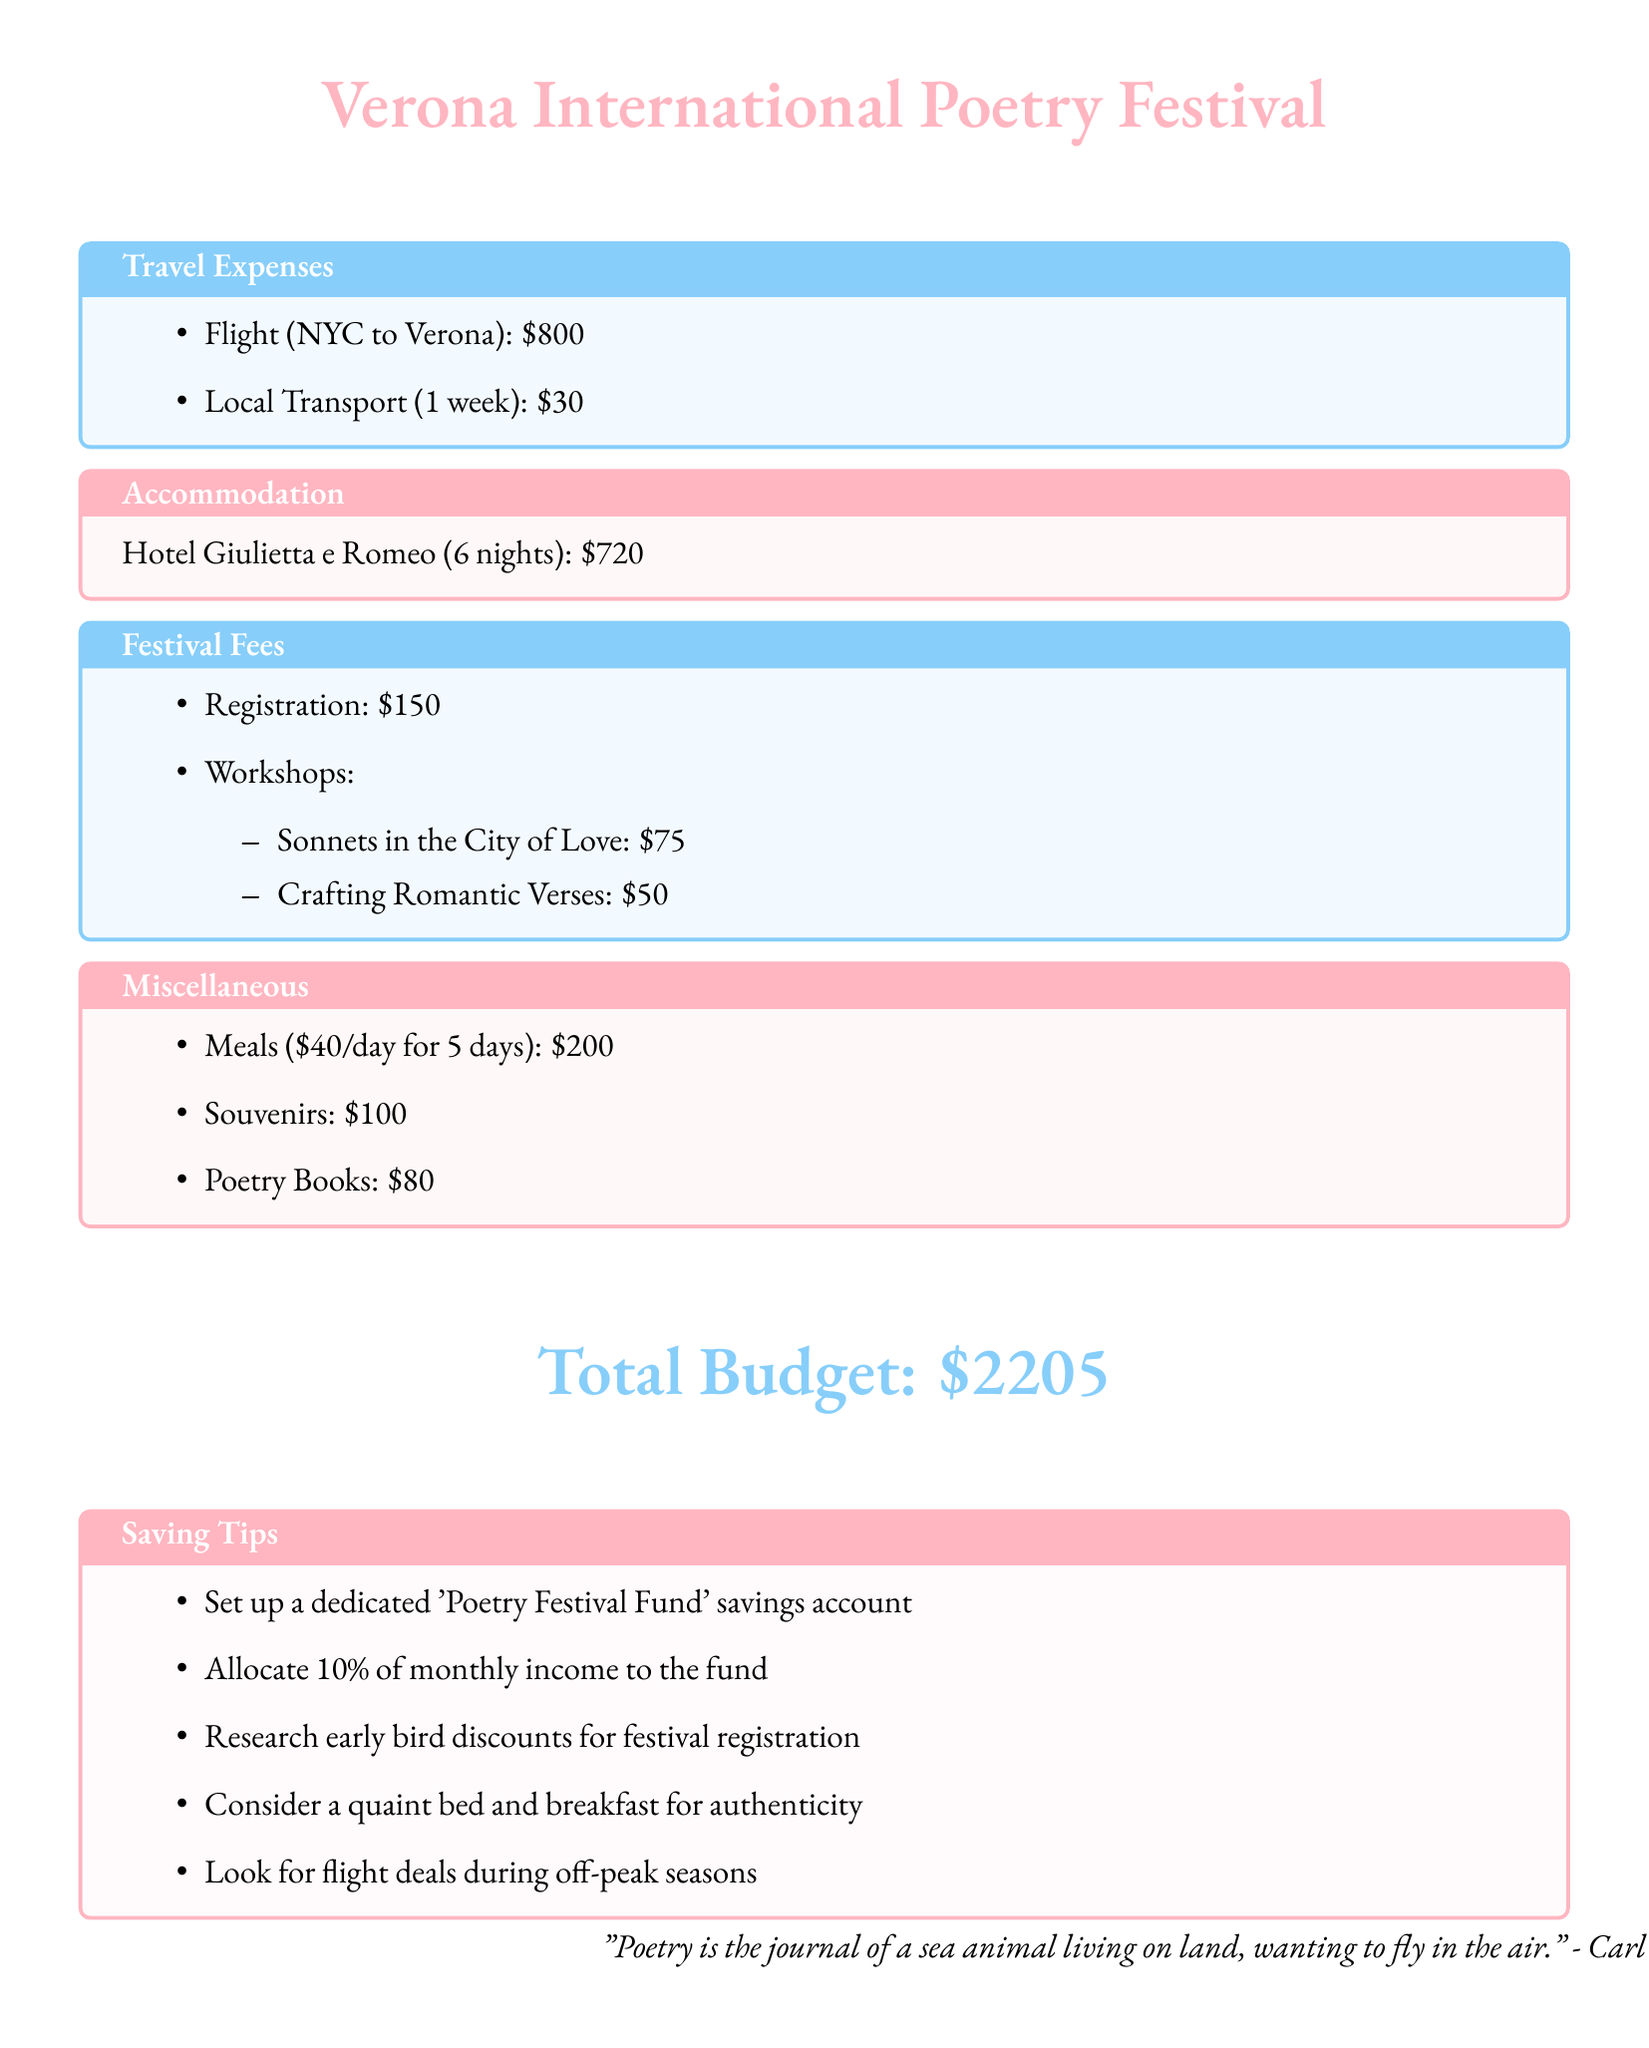What is the cost of the flight from NYC to Verona? The flight cost from NYC to Verona is listed in the travel expenses section of the document.
Answer: $800 How many nights will you stay at Hotel Giulietta e Romeo? The accommodation section specifies the duration of the stay at the hotel.
Answer: 6 nights What is the total cost for the workshops? The total cost for the workshops can be calculated by adding the individual workshop fees listed in the festival fees section.
Answer: $125 What is the daily meal budget? The miscellaneous section mentions the daily budget allocated for meals over a specified duration.
Answer: $40 How much is allocated for souvenirs? The miscellaneous section contains a specified amount earmarked for souvenirs.
Answer: $100 What percentage of monthly income should be allocated to the 'Poetry Festival Fund'? The saving tips section suggests a specific allocation percentage for the fund.
Answer: 10% What is the total budget for attending the poetry festival? The total budget is provided at the end of the document summarizing all expenses.
Answer: $2205 What is one of the saving tips mentioned in the document? The saving tips section lists several strategies for saving money in preparation for the festival.
Answer: Set up a dedicated 'Poetry Festival Fund' savings account Which poetic festival is mentioned in the document? The title of the document indicates the festival being discussed.
Answer: Verona International Poetry Festival What is the amount budgeted for poetry books? The miscellaneous section lists the budget allocated specifically for purchasing poetry books.
Answer: $80 